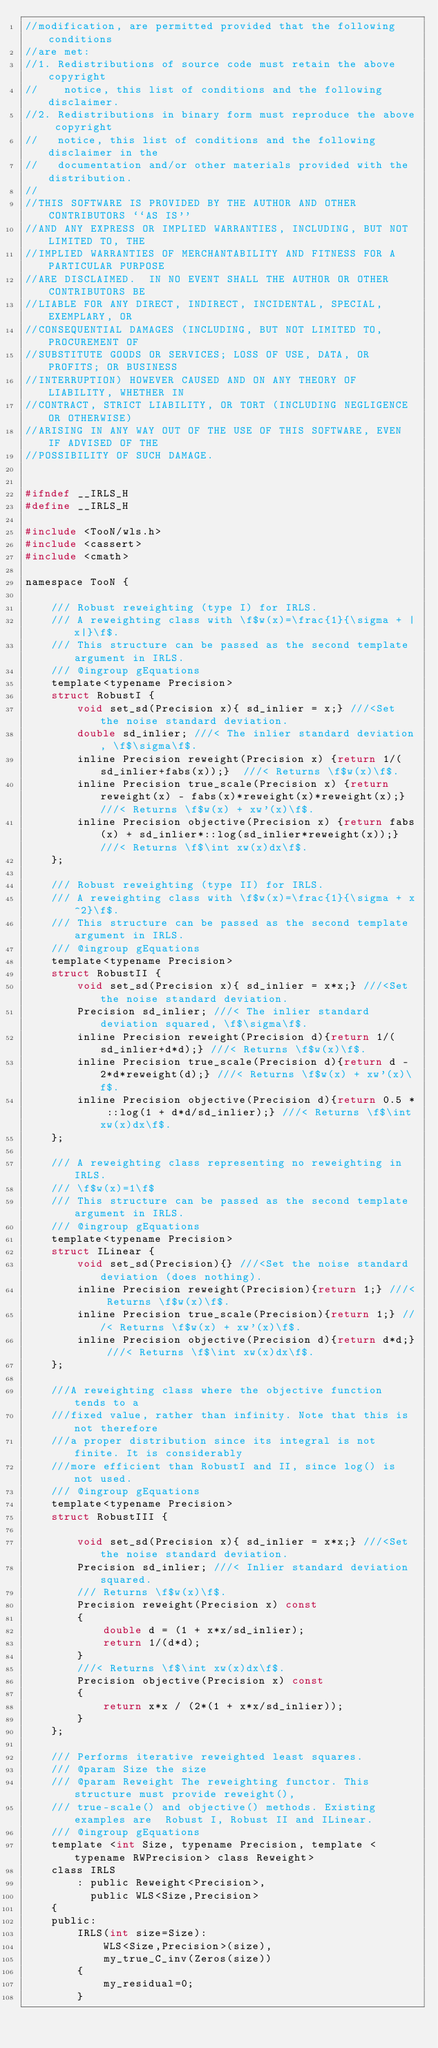<code> <loc_0><loc_0><loc_500><loc_500><_C_>//modification, are permitted provided that the following conditions
//are met:
//1. Redistributions of source code must retain the above copyright
//    notice, this list of conditions and the following disclaimer.
//2. Redistributions in binary form must reproduce the above copyright
//   notice, this list of conditions and the following disclaimer in the
//   documentation and/or other materials provided with the distribution.
//
//THIS SOFTWARE IS PROVIDED BY THE AUTHOR AND OTHER CONTRIBUTORS ``AS IS''
//AND ANY EXPRESS OR IMPLIED WARRANTIES, INCLUDING, BUT NOT LIMITED TO, THE
//IMPLIED WARRANTIES OF MERCHANTABILITY AND FITNESS FOR A PARTICULAR PURPOSE
//ARE DISCLAIMED.  IN NO EVENT SHALL THE AUTHOR OR OTHER CONTRIBUTORS BE
//LIABLE FOR ANY DIRECT, INDIRECT, INCIDENTAL, SPECIAL, EXEMPLARY, OR
//CONSEQUENTIAL DAMAGES (INCLUDING, BUT NOT LIMITED TO, PROCUREMENT OF
//SUBSTITUTE GOODS OR SERVICES; LOSS OF USE, DATA, OR PROFITS; OR BUSINESS
//INTERRUPTION) HOWEVER CAUSED AND ON ANY THEORY OF LIABILITY, WHETHER IN
//CONTRACT, STRICT LIABILITY, OR TORT (INCLUDING NEGLIGENCE OR OTHERWISE)
//ARISING IN ANY WAY OUT OF THE USE OF THIS SOFTWARE, EVEN IF ADVISED OF THE
//POSSIBILITY OF SUCH DAMAGE.


#ifndef __IRLS_H
#define __IRLS_H

#include <TooN/wls.h>
#include <cassert>
#include <cmath>

namespace TooN {

	/// Robust reweighting (type I) for IRLS.
	/// A reweighting class with \f$w(x)=\frac{1}{\sigma + |x|}\f$.
	/// This structure can be passed as the second template argument in IRLS.
	/// @ingroup gEquations
	template<typename Precision>
	struct RobustI {
		void set_sd(Precision x){ sd_inlier = x;} ///<Set the noise standard deviation.
		double sd_inlier; ///< The inlier standard deviation, \f$\sigma\f$.
		inline Precision reweight(Precision x) {return 1/(sd_inlier+fabs(x));}  ///< Returns \f$w(x)\f$.
		inline Precision true_scale(Precision x) {return reweight(x) - fabs(x)*reweight(x)*reweight(x);}  ///< Returns \f$w(x) + xw'(x)\f$.
		inline Precision objective(Precision x) {return fabs(x) + sd_inlier*::log(sd_inlier*reweight(x));}  ///< Returns \f$\int xw(x)dx\f$.
	};

	/// Robust reweighting (type II) for IRLS.
	/// A reweighting class with \f$w(x)=\frac{1}{\sigma + x^2}\f$.
	/// This structure can be passed as the second template argument in IRLS.
	/// @ingroup gEquations
	template<typename Precision>
	struct RobustII {
		void set_sd(Precision x){ sd_inlier = x*x;} ///<Set the noise standard deviation.
		Precision sd_inlier; ///< The inlier standard deviation squared, \f$\sigma\f$.
		inline Precision reweight(Precision d){return 1/(sd_inlier+d*d);} ///< Returns \f$w(x)\f$.
		inline Precision true_scale(Precision d){return d - 2*d*reweight(d);} ///< Returns \f$w(x) + xw'(x)\f$.
		inline Precision objective(Precision d){return 0.5 * ::log(1 + d*d/sd_inlier);} ///< Returns \f$\int xw(x)dx\f$.
	};

	/// A reweighting class representing no reweighting in IRLS.
	/// \f$w(x)=1\f$
	/// This structure can be passed as the second template argument in IRLS.
	/// @ingroup gEquations
	template<typename Precision>
	struct ILinear {
		void set_sd(Precision){} ///<Set the noise standard deviation (does nothing).
		inline Precision reweight(Precision){return 1;} ///< Returns \f$w(x)\f$.
		inline Precision true_scale(Precision){return 1;} ///< Returns \f$w(x) + xw'(x)\f$.
		inline Precision objective(Precision d){return d*d;} ///< Returns \f$\int xw(x)dx\f$.
	};
	
	///A reweighting class where the objective function tends to a 
	///fixed value, rather than infinity. Note that this is not therefore
	///a proper distribution since its integral is not finite. It is considerably
	///more efficient than RobustI and II, since log() is not used.
	/// @ingroup gEquations
	template<typename Precision>
	struct RobustIII {

		void set_sd(Precision x){ sd_inlier = x*x;} ///<Set the noise standard deviation.
		Precision sd_inlier; ///< Inlier standard deviation squared.
		/// Returns \f$w(x)\f$.
		Precision reweight(Precision x) const
		{
			double d = (1 + x*x/sd_inlier);
			return 1/(d*d);
		}	
		///< Returns \f$\int xw(x)dx\f$.
		Precision objective(Precision x) const 
		{
			return x*x / (2*(1 + x*x/sd_inlier));
		}
	};

	/// Performs iterative reweighted least squares.
	/// @param Size the size
	/// @param Reweight The reweighting functor. This structure must provide reweight(), 
	/// true-scale() and objective() methods. Existing examples are  Robust I, Robust II and ILinear.
	/// @ingroup gEquations
	template <int Size, typename Precision, template <typename RWPrecision> class Reweight>
	class IRLS
		: public Reweight<Precision>,
		  public WLS<Size,Precision>
	{
	public:
		IRLS(int size=Size):
			WLS<Size,Precision>(size),
			my_true_C_inv(Zeros(size))
		{
			my_residual=0;
		}
		</code> 